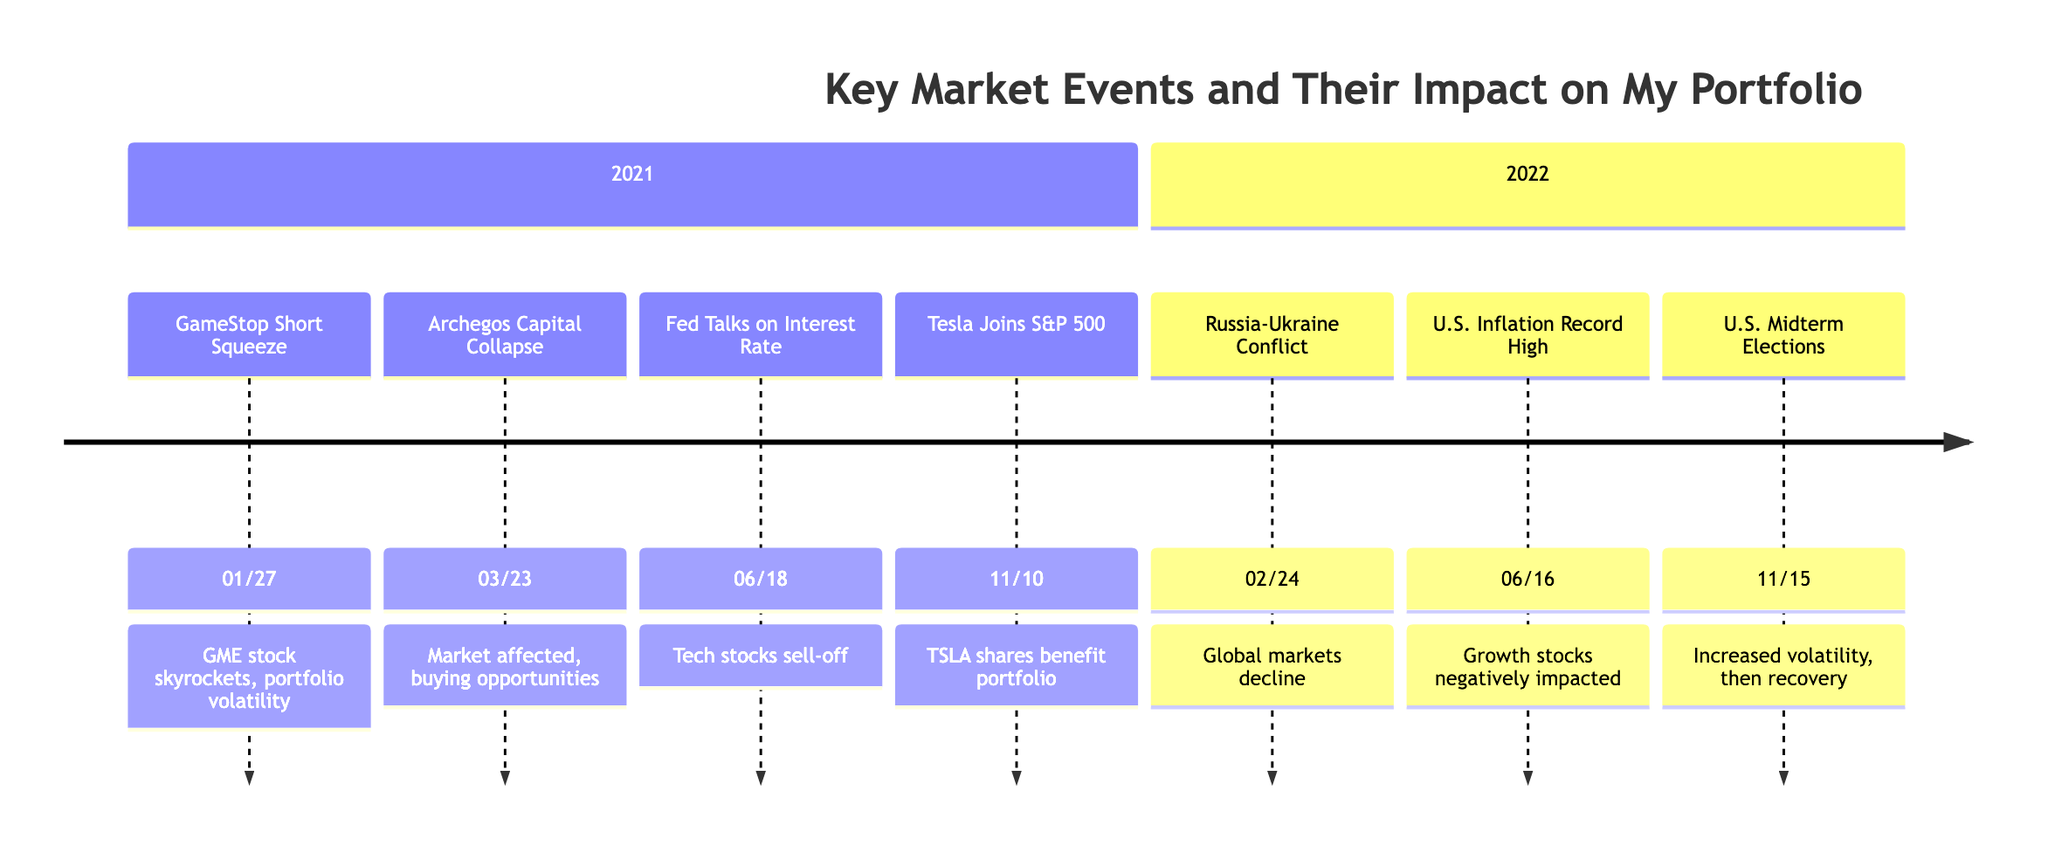What event happened on January 27, 2021? Looking at the timeline, the event listed on January 27, 2021, is "GameStop Short Squeeze."
Answer: GameStop Short Squeeze How did the Federal Reserve talks on interest rate hikes impact my portfolio on June 18, 2021? The timeline states that the announcements led to a sell-off in high-growth tech stocks, which would have negatively affected a tech-heavy portfolio.
Answer: Sell-off in high-growth tech stocks What significant market event occurred on March 23, 2021? The event listed for March 23, 2021, is the "Archegos Capital Management Collapse."
Answer: Archegos Capital Management Collapse What was the market's reaction to the U.S. Midterm Elections on November 15, 2022? The timeline indicates that there was increased volatility during the elections, but after the results, market sentiment improved, leading to a recovery in my portfolio.
Answer: Increased volatility, then recovery Which event led to a sharp decline in global markets on February 24, 2022? According to the timeline, the event on February 24, 2022, is the "Russia-Ukraine Conflict," which caused the mentioned decline.
Answer: Russia-Ukraine Conflict How many significant events are recorded in the timeline? Counting the events listed in the timeline, there are a total of 6 significant events from 2021 and 2022 combined.
Answer: 6 What was the primary impact on my portfolio due to inflation reaching record highs on June 16, 2022? The timeline states that the record-high inflation negatively impacted growth stocks in my portfolio due to fears of aggressive Fed rate hikes.
Answer: Negatively impacted growth stocks Which stock benefited from Tesla’s inclusion in the S&P 500 on November 10, 2021? The timeline specifies that my portfolio benefited due to my investment in TSLA shares as a result of Tesla's inclusion.
Answer: TSLA shares What event contributed to market jitters in June 2021? The event listed for June 18, 2021, is the "Federal Reserve Talks on Interest Rate Hike," which caused market jitters.
Answer: Federal Reserve Talks on Interest Rate Hike 